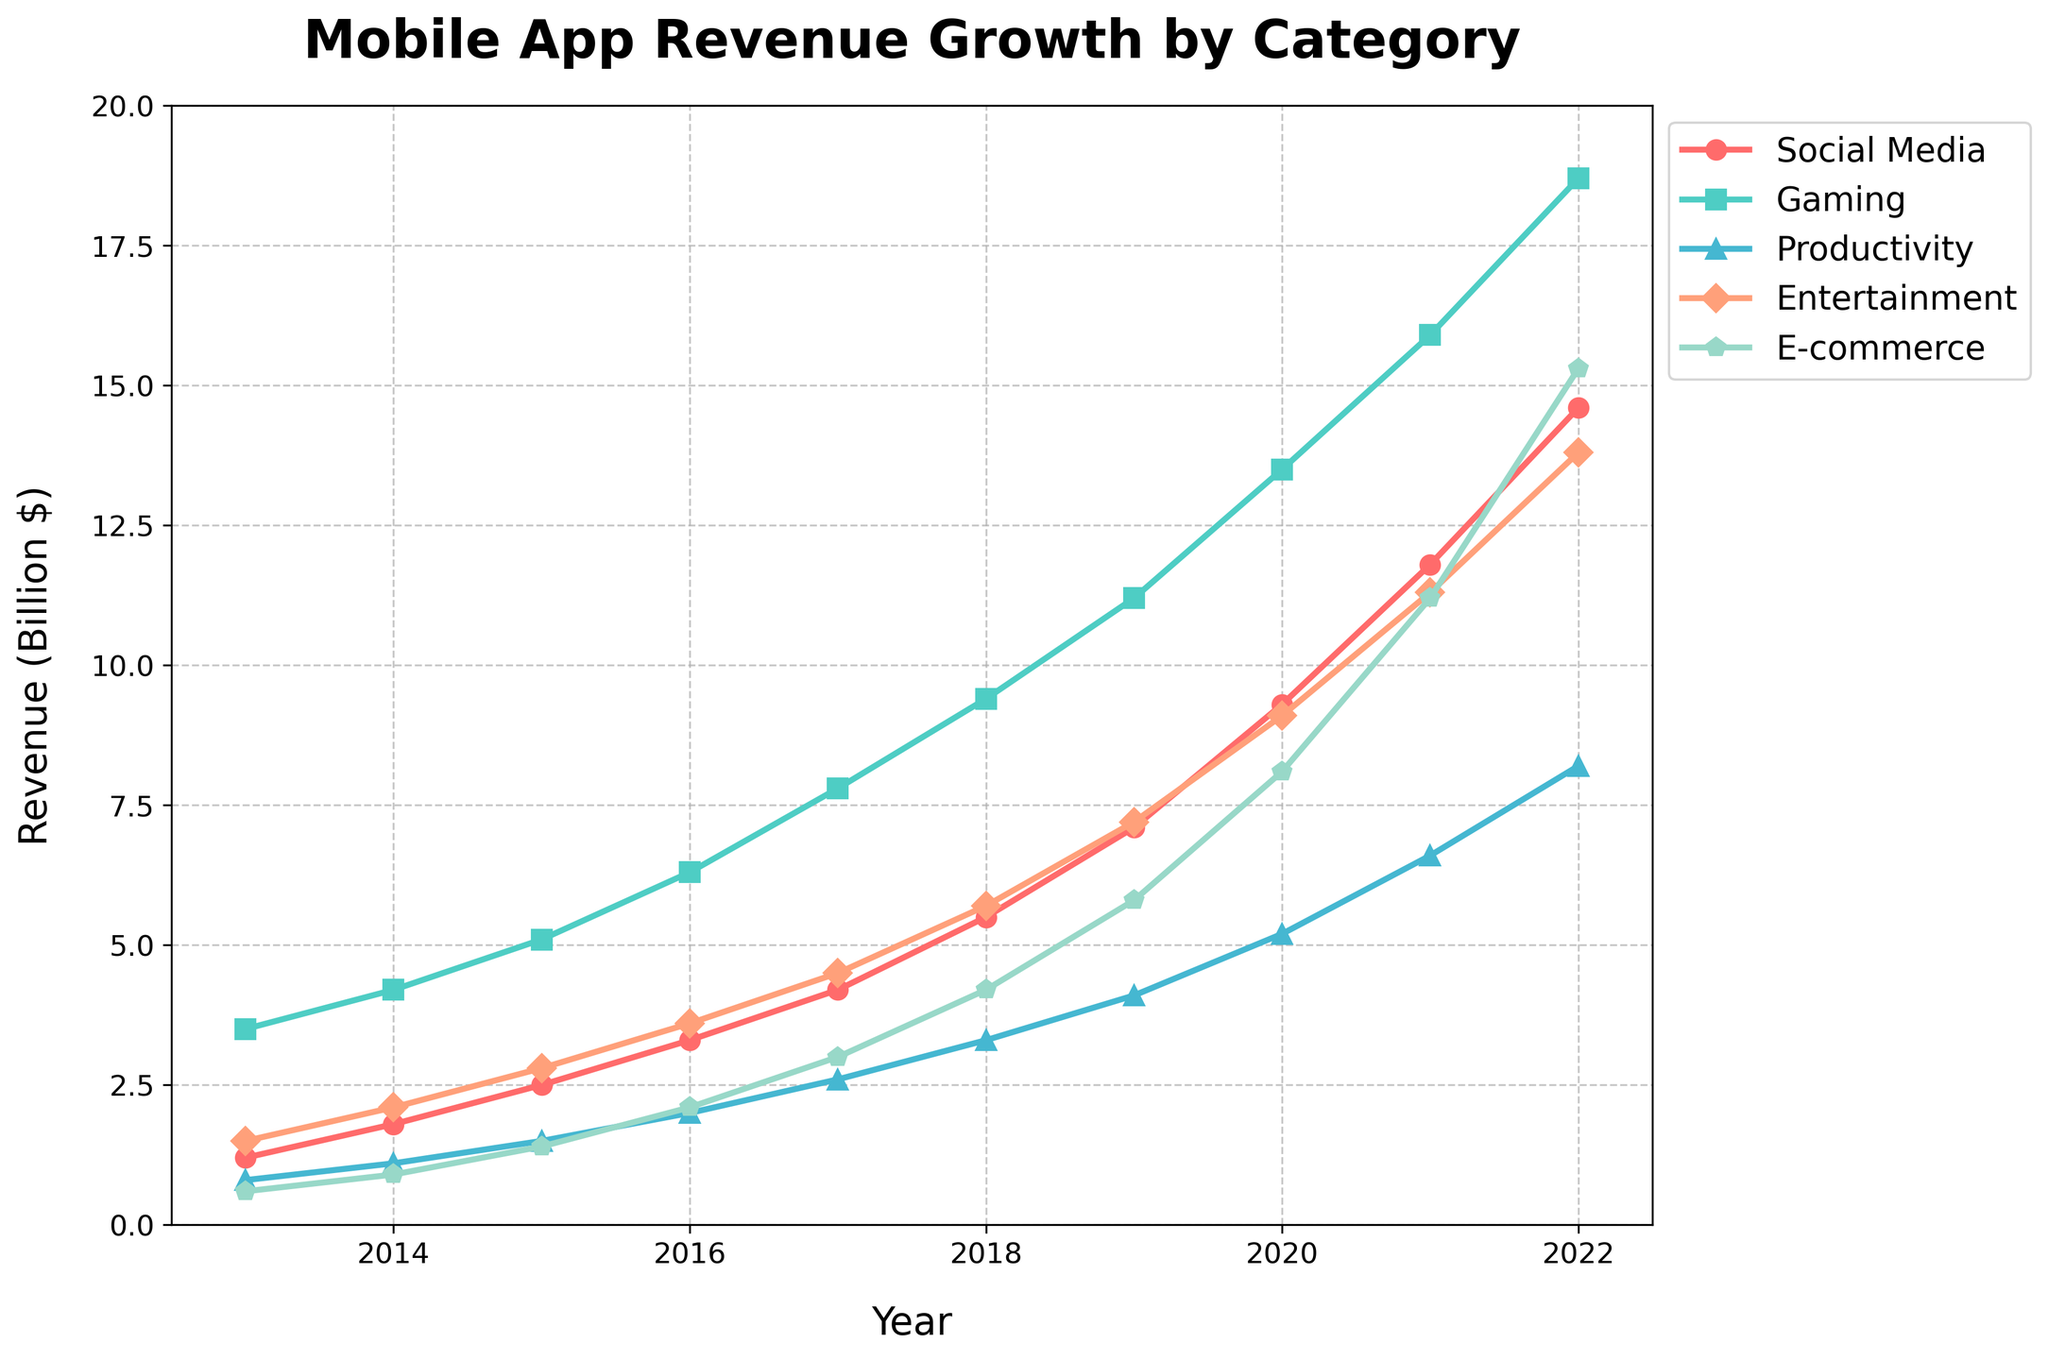Which category showed the highest revenue in 2022? Look at the points for all categories at the year 2022 on the x-axis. The highest point corresponds to the E-commerce category with a revenue of 15.3 billion dollars.
Answer: E-commerce What is the difference in revenue between Gaming and Social Media in 2020? In 2020, Gaming revenue is 13.5 billion dollars and Social Media revenue is 9.3 billion dollars. Subtracting 9.3 from 13.5 gives 4.2 billion dollars.
Answer: 4.2 billion dollars Which category had the lowest growth rate from 2019 to 2022? Calculate the difference in revenues for each category from 2019 to 2022 and compare. Social Media increased from 7.1 to 14.6 (7.5), Gaming from 11.2 to 18.7 (7.5), Productivity from 4.1 to 8.2 (4.1), Entertainment from 7.2 to 13.8 (6.6), and E-commerce from 5.8 to 15.3 (9.5). Productivity had the lowest growth rate with an increase of 4.1 billion dollars.
Answer: Productivity Which year did Productivity revenue surpass 2 billion dollars? Trace the Productivity line and notice at which year the value exceeds the 2 billion mark. It occurred between 2015 and 2016, specifically in 2016 with revenue of 2.0 billion dollars.
Answer: 2016 What are the average yearly revenue growths for each category from 2013 to 2022? Calculate the yearly growth for each year and each category first, and then take the average. For Social Media: (1.8-1.2)+(2.5-1.8)+(3.3-2.5)+(4.2-3.3)+(5.5-4.2)+(7.1-5.5)+(9.3-7.1)+(11.8-9.3)+(14.6-11.8) = 13.4/9=1.489. For Gaming: 16.2/9 = 1.8. For Productivity: 7.4/9 = 0.822. For Entertainment: 12.3/9 = 1.366. For E-commerce: 14.7/9 = 1.63. Social Media (~1.49), Gaming (~1.80), Productivity (~0.82), Entertainment (~1.37), E-commerce (~1.63).
Answer: Social Media (~1.49), Gaming (~1.80), Productivity (~0.82), Entertainment (~1.37), E-commerce (~1.63) Which category was the second highest in revenue in 2017? Look at the revenue points for the year 2017; Social Media is 4.2, Gaming is 7.8, Productivity is 2.6, Entertainment is 4.5, and E-commerce is 3.0. The second-highest revenue belongs to Entertainment with 4.5 billion dollars.
Answer: Entertainment How much did E-commerce revenue increase from 2013 to 2022? Compare E-commerce revenue at 2013 (0.6 billion dollars) to revenue at 2022 (15.3 billion dollars). The increase is 15.3 - 0.6 = 14.7 billion dollars.
Answer: 14.7 billion dollars In which year did Gaming revenue reach 10 billion dollars? Trace the Gaming revenue line to the point where it hits 10 billion dollars. This occurred between 2018 and 2019, specifically in 2019 with revenue at 11.2 billion dollars.
Answer: 2019 Which categories had higher revenue than Social Media in 2014? Compare the Social Media revenue in 2014 (1.8 billion dollars) with other categories in the same year: Gaming (4.2 billion dollars) and Entertainment (2.1 billion dollars) had higher revenues than Social Media.
Answer: Gaming, Entertainment 